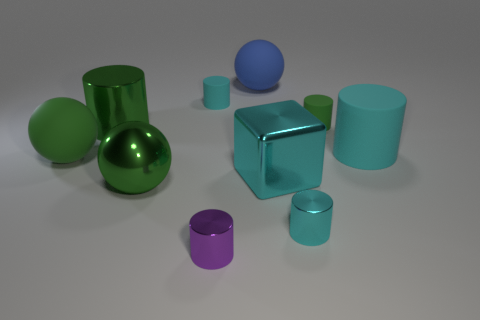Subtract all green rubber balls. How many balls are left? 2 Subtract all purple cylinders. How many cylinders are left? 5 Subtract all cubes. How many objects are left? 9 Subtract 0 gray cylinders. How many objects are left? 10 Subtract 1 balls. How many balls are left? 2 Subtract all green spheres. Subtract all cyan cylinders. How many spheres are left? 1 Subtract all green cylinders. How many gray spheres are left? 0 Subtract all brown shiny blocks. Subtract all cylinders. How many objects are left? 4 Add 6 cyan cylinders. How many cyan cylinders are left? 9 Add 7 green cylinders. How many green cylinders exist? 9 